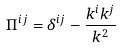<formula> <loc_0><loc_0><loc_500><loc_500>\Pi ^ { i j } = \delta ^ { i j } - \frac { k ^ { i } k ^ { j } } { k ^ { 2 } }</formula> 